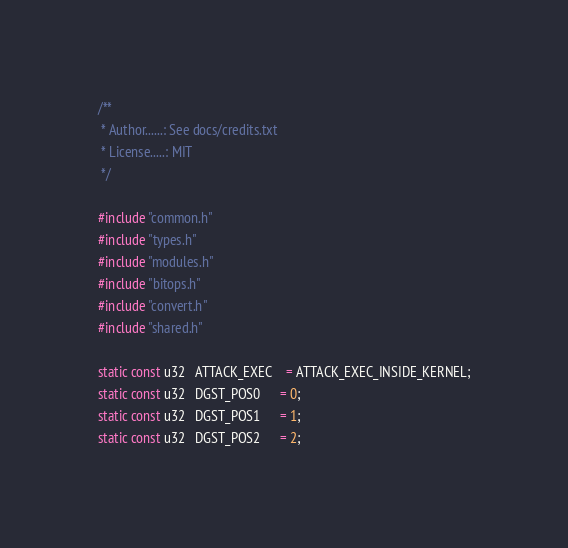<code> <loc_0><loc_0><loc_500><loc_500><_C_>/**
 * Author......: See docs/credits.txt
 * License.....: MIT
 */

#include "common.h"
#include "types.h"
#include "modules.h"
#include "bitops.h"
#include "convert.h"
#include "shared.h"

static const u32   ATTACK_EXEC    = ATTACK_EXEC_INSIDE_KERNEL;
static const u32   DGST_POS0      = 0;
static const u32   DGST_POS1      = 1;
static const u32   DGST_POS2      = 2;</code> 